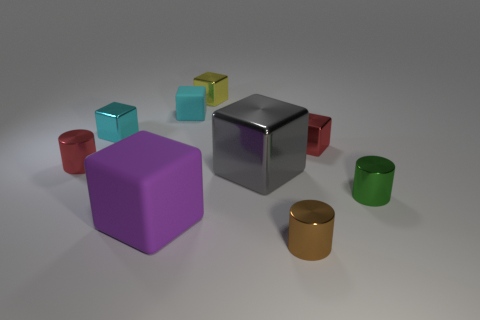Are any large purple rubber things visible?
Your answer should be compact. Yes. What is the color of the block that is in front of the red cylinder and on the right side of the cyan matte thing?
Your response must be concise. Gray. There is a block to the right of the tiny brown metallic cylinder; does it have the same size as the yellow thing that is to the left of the green shiny object?
Your answer should be compact. Yes. What number of other things are there of the same size as the green object?
Ensure brevity in your answer.  6. There is a red metal thing that is to the left of the small brown thing; what number of metal cylinders are behind it?
Give a very brief answer. 0. Is the number of large gray blocks that are right of the red shiny cube less than the number of large purple rubber balls?
Offer a terse response. No. The rubber thing that is behind the block that is in front of the cylinder right of the brown thing is what shape?
Provide a short and direct response. Cube. Is the shape of the small cyan matte thing the same as the purple object?
Give a very brief answer. Yes. How many other things are there of the same shape as the large purple matte thing?
Provide a succinct answer. 5. The matte block that is the same size as the cyan metallic object is what color?
Provide a succinct answer. Cyan. 